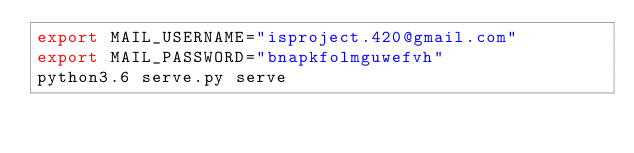Convert code to text. <code><loc_0><loc_0><loc_500><loc_500><_Bash_>export MAIL_USERNAME="isproject.420@gmail.com"
export MAIL_PASSWORD="bnapkfolmguwefvh"
python3.6 serve.py serve
</code> 